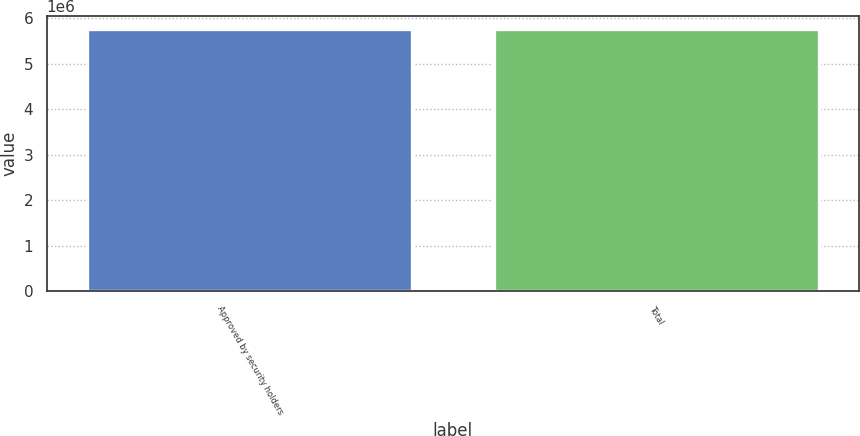Convert chart. <chart><loc_0><loc_0><loc_500><loc_500><bar_chart><fcel>Approved by security holders<fcel>Total<nl><fcel>5.76471e+06<fcel>5.76471e+06<nl></chart> 